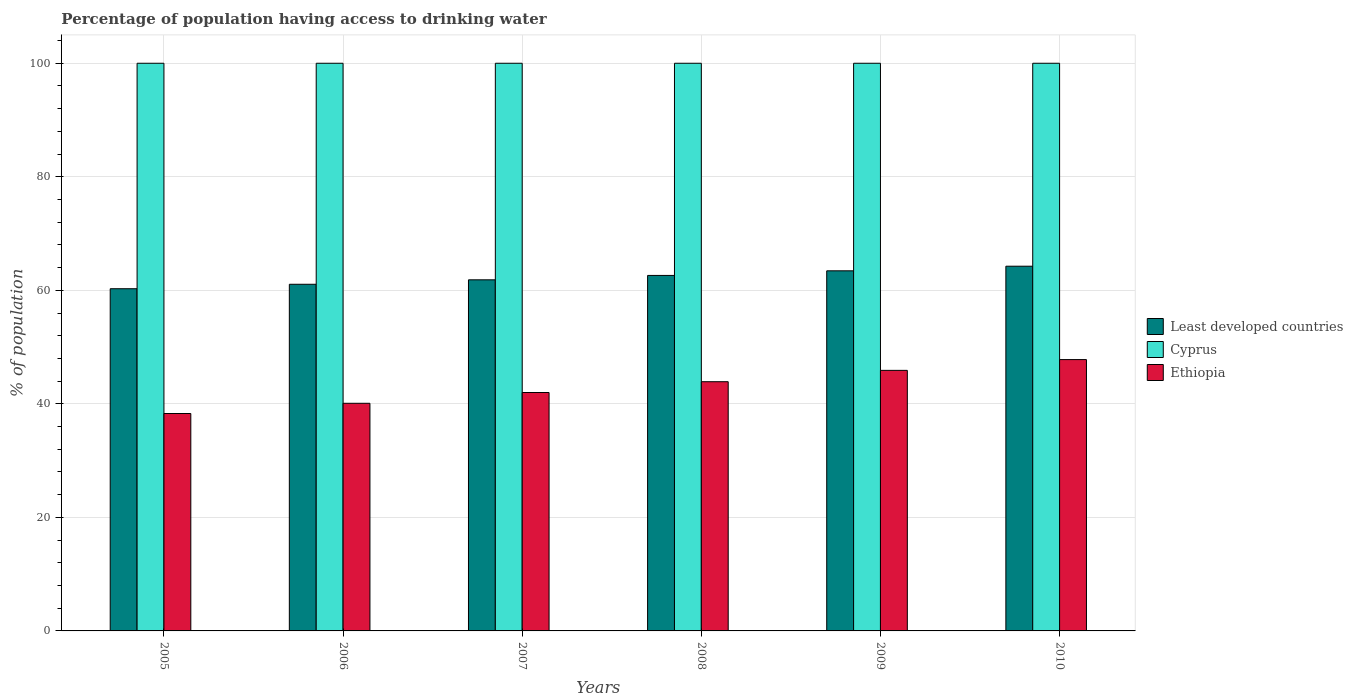How many different coloured bars are there?
Keep it short and to the point. 3. Are the number of bars per tick equal to the number of legend labels?
Your answer should be compact. Yes. What is the label of the 2nd group of bars from the left?
Your response must be concise. 2006. What is the percentage of population having access to drinking water in Least developed countries in 2007?
Your answer should be compact. 61.85. Across all years, what is the maximum percentage of population having access to drinking water in Ethiopia?
Your response must be concise. 47.8. Across all years, what is the minimum percentage of population having access to drinking water in Ethiopia?
Provide a succinct answer. 38.3. In which year was the percentage of population having access to drinking water in Cyprus minimum?
Offer a terse response. 2005. What is the total percentage of population having access to drinking water in Cyprus in the graph?
Make the answer very short. 600. What is the difference between the percentage of population having access to drinking water in Least developed countries in 2008 and that in 2010?
Your answer should be compact. -1.62. What is the difference between the percentage of population having access to drinking water in Ethiopia in 2007 and the percentage of population having access to drinking water in Cyprus in 2006?
Keep it short and to the point. -58. In the year 2007, what is the difference between the percentage of population having access to drinking water in Least developed countries and percentage of population having access to drinking water in Cyprus?
Offer a terse response. -38.15. In how many years, is the percentage of population having access to drinking water in Least developed countries greater than 44 %?
Provide a succinct answer. 6. What is the ratio of the percentage of population having access to drinking water in Cyprus in 2008 to that in 2009?
Keep it short and to the point. 1. Is the difference between the percentage of population having access to drinking water in Least developed countries in 2007 and 2010 greater than the difference between the percentage of population having access to drinking water in Cyprus in 2007 and 2010?
Your response must be concise. No. What is the difference between the highest and the second highest percentage of population having access to drinking water in Ethiopia?
Your response must be concise. 1.9. What is the difference between the highest and the lowest percentage of population having access to drinking water in Cyprus?
Offer a very short reply. 0. In how many years, is the percentage of population having access to drinking water in Cyprus greater than the average percentage of population having access to drinking water in Cyprus taken over all years?
Ensure brevity in your answer.  0. Is the sum of the percentage of population having access to drinking water in Ethiopia in 2006 and 2010 greater than the maximum percentage of population having access to drinking water in Least developed countries across all years?
Keep it short and to the point. Yes. What does the 3rd bar from the left in 2008 represents?
Offer a terse response. Ethiopia. What does the 3rd bar from the right in 2006 represents?
Your response must be concise. Least developed countries. How many years are there in the graph?
Offer a very short reply. 6. Are the values on the major ticks of Y-axis written in scientific E-notation?
Offer a terse response. No. Does the graph contain any zero values?
Offer a very short reply. No. Does the graph contain grids?
Provide a short and direct response. Yes. Where does the legend appear in the graph?
Your answer should be very brief. Center right. How many legend labels are there?
Make the answer very short. 3. What is the title of the graph?
Keep it short and to the point. Percentage of population having access to drinking water. What is the label or title of the Y-axis?
Make the answer very short. % of population. What is the % of population of Least developed countries in 2005?
Give a very brief answer. 60.28. What is the % of population in Ethiopia in 2005?
Offer a terse response. 38.3. What is the % of population of Least developed countries in 2006?
Offer a terse response. 61.06. What is the % of population of Ethiopia in 2006?
Provide a short and direct response. 40.1. What is the % of population in Least developed countries in 2007?
Offer a very short reply. 61.85. What is the % of population in Cyprus in 2007?
Keep it short and to the point. 100. What is the % of population of Least developed countries in 2008?
Make the answer very short. 62.62. What is the % of population of Cyprus in 2008?
Make the answer very short. 100. What is the % of population of Ethiopia in 2008?
Your answer should be compact. 43.9. What is the % of population of Least developed countries in 2009?
Give a very brief answer. 63.44. What is the % of population in Cyprus in 2009?
Offer a very short reply. 100. What is the % of population of Ethiopia in 2009?
Make the answer very short. 45.9. What is the % of population in Least developed countries in 2010?
Your response must be concise. 64.25. What is the % of population of Ethiopia in 2010?
Make the answer very short. 47.8. Across all years, what is the maximum % of population in Least developed countries?
Ensure brevity in your answer.  64.25. Across all years, what is the maximum % of population in Cyprus?
Offer a very short reply. 100. Across all years, what is the maximum % of population of Ethiopia?
Your answer should be very brief. 47.8. Across all years, what is the minimum % of population of Least developed countries?
Your answer should be compact. 60.28. Across all years, what is the minimum % of population of Ethiopia?
Your answer should be compact. 38.3. What is the total % of population of Least developed countries in the graph?
Your answer should be very brief. 373.5. What is the total % of population of Cyprus in the graph?
Provide a short and direct response. 600. What is the total % of population of Ethiopia in the graph?
Offer a very short reply. 258. What is the difference between the % of population of Least developed countries in 2005 and that in 2006?
Your response must be concise. -0.78. What is the difference between the % of population of Cyprus in 2005 and that in 2006?
Your answer should be compact. 0. What is the difference between the % of population in Least developed countries in 2005 and that in 2007?
Provide a short and direct response. -1.57. What is the difference between the % of population of Least developed countries in 2005 and that in 2008?
Make the answer very short. -2.34. What is the difference between the % of population of Least developed countries in 2005 and that in 2009?
Keep it short and to the point. -3.15. What is the difference between the % of population of Least developed countries in 2005 and that in 2010?
Provide a short and direct response. -3.97. What is the difference between the % of population of Ethiopia in 2005 and that in 2010?
Keep it short and to the point. -9.5. What is the difference between the % of population in Least developed countries in 2006 and that in 2007?
Your response must be concise. -0.78. What is the difference between the % of population of Cyprus in 2006 and that in 2007?
Ensure brevity in your answer.  0. What is the difference between the % of population in Ethiopia in 2006 and that in 2007?
Your response must be concise. -1.9. What is the difference between the % of population in Least developed countries in 2006 and that in 2008?
Offer a very short reply. -1.56. What is the difference between the % of population of Least developed countries in 2006 and that in 2009?
Provide a succinct answer. -2.37. What is the difference between the % of population of Least developed countries in 2006 and that in 2010?
Keep it short and to the point. -3.18. What is the difference between the % of population in Least developed countries in 2007 and that in 2008?
Keep it short and to the point. -0.77. What is the difference between the % of population of Cyprus in 2007 and that in 2008?
Ensure brevity in your answer.  0. What is the difference between the % of population in Least developed countries in 2007 and that in 2009?
Your response must be concise. -1.59. What is the difference between the % of population in Least developed countries in 2007 and that in 2010?
Keep it short and to the point. -2.4. What is the difference between the % of population in Least developed countries in 2008 and that in 2009?
Offer a very short reply. -0.81. What is the difference between the % of population of Ethiopia in 2008 and that in 2009?
Your answer should be compact. -2. What is the difference between the % of population in Least developed countries in 2008 and that in 2010?
Your response must be concise. -1.62. What is the difference between the % of population of Cyprus in 2008 and that in 2010?
Provide a short and direct response. 0. What is the difference between the % of population of Least developed countries in 2009 and that in 2010?
Make the answer very short. -0.81. What is the difference between the % of population of Ethiopia in 2009 and that in 2010?
Ensure brevity in your answer.  -1.9. What is the difference between the % of population in Least developed countries in 2005 and the % of population in Cyprus in 2006?
Offer a terse response. -39.72. What is the difference between the % of population in Least developed countries in 2005 and the % of population in Ethiopia in 2006?
Offer a terse response. 20.18. What is the difference between the % of population in Cyprus in 2005 and the % of population in Ethiopia in 2006?
Provide a succinct answer. 59.9. What is the difference between the % of population in Least developed countries in 2005 and the % of population in Cyprus in 2007?
Provide a succinct answer. -39.72. What is the difference between the % of population in Least developed countries in 2005 and the % of population in Ethiopia in 2007?
Keep it short and to the point. 18.28. What is the difference between the % of population in Least developed countries in 2005 and the % of population in Cyprus in 2008?
Keep it short and to the point. -39.72. What is the difference between the % of population in Least developed countries in 2005 and the % of population in Ethiopia in 2008?
Your answer should be very brief. 16.38. What is the difference between the % of population in Cyprus in 2005 and the % of population in Ethiopia in 2008?
Give a very brief answer. 56.1. What is the difference between the % of population of Least developed countries in 2005 and the % of population of Cyprus in 2009?
Make the answer very short. -39.72. What is the difference between the % of population of Least developed countries in 2005 and the % of population of Ethiopia in 2009?
Your answer should be compact. 14.38. What is the difference between the % of population of Cyprus in 2005 and the % of population of Ethiopia in 2009?
Your answer should be compact. 54.1. What is the difference between the % of population in Least developed countries in 2005 and the % of population in Cyprus in 2010?
Give a very brief answer. -39.72. What is the difference between the % of population in Least developed countries in 2005 and the % of population in Ethiopia in 2010?
Your answer should be compact. 12.48. What is the difference between the % of population of Cyprus in 2005 and the % of population of Ethiopia in 2010?
Provide a succinct answer. 52.2. What is the difference between the % of population of Least developed countries in 2006 and the % of population of Cyprus in 2007?
Your response must be concise. -38.94. What is the difference between the % of population in Least developed countries in 2006 and the % of population in Ethiopia in 2007?
Provide a succinct answer. 19.06. What is the difference between the % of population in Cyprus in 2006 and the % of population in Ethiopia in 2007?
Provide a succinct answer. 58. What is the difference between the % of population in Least developed countries in 2006 and the % of population in Cyprus in 2008?
Keep it short and to the point. -38.94. What is the difference between the % of population in Least developed countries in 2006 and the % of population in Ethiopia in 2008?
Provide a short and direct response. 17.16. What is the difference between the % of population of Cyprus in 2006 and the % of population of Ethiopia in 2008?
Your answer should be compact. 56.1. What is the difference between the % of population in Least developed countries in 2006 and the % of population in Cyprus in 2009?
Give a very brief answer. -38.94. What is the difference between the % of population in Least developed countries in 2006 and the % of population in Ethiopia in 2009?
Give a very brief answer. 15.16. What is the difference between the % of population in Cyprus in 2006 and the % of population in Ethiopia in 2009?
Offer a very short reply. 54.1. What is the difference between the % of population in Least developed countries in 2006 and the % of population in Cyprus in 2010?
Your answer should be very brief. -38.94. What is the difference between the % of population of Least developed countries in 2006 and the % of population of Ethiopia in 2010?
Offer a very short reply. 13.26. What is the difference between the % of population in Cyprus in 2006 and the % of population in Ethiopia in 2010?
Your answer should be very brief. 52.2. What is the difference between the % of population of Least developed countries in 2007 and the % of population of Cyprus in 2008?
Provide a succinct answer. -38.15. What is the difference between the % of population in Least developed countries in 2007 and the % of population in Ethiopia in 2008?
Give a very brief answer. 17.95. What is the difference between the % of population in Cyprus in 2007 and the % of population in Ethiopia in 2008?
Provide a short and direct response. 56.1. What is the difference between the % of population in Least developed countries in 2007 and the % of population in Cyprus in 2009?
Provide a short and direct response. -38.15. What is the difference between the % of population of Least developed countries in 2007 and the % of population of Ethiopia in 2009?
Make the answer very short. 15.95. What is the difference between the % of population in Cyprus in 2007 and the % of population in Ethiopia in 2009?
Give a very brief answer. 54.1. What is the difference between the % of population of Least developed countries in 2007 and the % of population of Cyprus in 2010?
Provide a short and direct response. -38.15. What is the difference between the % of population of Least developed countries in 2007 and the % of population of Ethiopia in 2010?
Provide a succinct answer. 14.05. What is the difference between the % of population in Cyprus in 2007 and the % of population in Ethiopia in 2010?
Provide a succinct answer. 52.2. What is the difference between the % of population in Least developed countries in 2008 and the % of population in Cyprus in 2009?
Give a very brief answer. -37.38. What is the difference between the % of population of Least developed countries in 2008 and the % of population of Ethiopia in 2009?
Keep it short and to the point. 16.72. What is the difference between the % of population of Cyprus in 2008 and the % of population of Ethiopia in 2009?
Make the answer very short. 54.1. What is the difference between the % of population in Least developed countries in 2008 and the % of population in Cyprus in 2010?
Your answer should be very brief. -37.38. What is the difference between the % of population of Least developed countries in 2008 and the % of population of Ethiopia in 2010?
Provide a succinct answer. 14.82. What is the difference between the % of population in Cyprus in 2008 and the % of population in Ethiopia in 2010?
Ensure brevity in your answer.  52.2. What is the difference between the % of population of Least developed countries in 2009 and the % of population of Cyprus in 2010?
Your answer should be very brief. -36.56. What is the difference between the % of population in Least developed countries in 2009 and the % of population in Ethiopia in 2010?
Give a very brief answer. 15.64. What is the difference between the % of population of Cyprus in 2009 and the % of population of Ethiopia in 2010?
Offer a very short reply. 52.2. What is the average % of population of Least developed countries per year?
Offer a very short reply. 62.25. What is the average % of population in Ethiopia per year?
Your response must be concise. 43. In the year 2005, what is the difference between the % of population in Least developed countries and % of population in Cyprus?
Make the answer very short. -39.72. In the year 2005, what is the difference between the % of population in Least developed countries and % of population in Ethiopia?
Make the answer very short. 21.98. In the year 2005, what is the difference between the % of population in Cyprus and % of population in Ethiopia?
Provide a succinct answer. 61.7. In the year 2006, what is the difference between the % of population in Least developed countries and % of population in Cyprus?
Provide a succinct answer. -38.94. In the year 2006, what is the difference between the % of population of Least developed countries and % of population of Ethiopia?
Keep it short and to the point. 20.96. In the year 2006, what is the difference between the % of population of Cyprus and % of population of Ethiopia?
Your answer should be compact. 59.9. In the year 2007, what is the difference between the % of population in Least developed countries and % of population in Cyprus?
Provide a succinct answer. -38.15. In the year 2007, what is the difference between the % of population of Least developed countries and % of population of Ethiopia?
Ensure brevity in your answer.  19.85. In the year 2007, what is the difference between the % of population in Cyprus and % of population in Ethiopia?
Ensure brevity in your answer.  58. In the year 2008, what is the difference between the % of population of Least developed countries and % of population of Cyprus?
Offer a very short reply. -37.38. In the year 2008, what is the difference between the % of population in Least developed countries and % of population in Ethiopia?
Provide a short and direct response. 18.72. In the year 2008, what is the difference between the % of population of Cyprus and % of population of Ethiopia?
Offer a terse response. 56.1. In the year 2009, what is the difference between the % of population in Least developed countries and % of population in Cyprus?
Make the answer very short. -36.56. In the year 2009, what is the difference between the % of population of Least developed countries and % of population of Ethiopia?
Give a very brief answer. 17.54. In the year 2009, what is the difference between the % of population of Cyprus and % of population of Ethiopia?
Keep it short and to the point. 54.1. In the year 2010, what is the difference between the % of population of Least developed countries and % of population of Cyprus?
Your answer should be compact. -35.75. In the year 2010, what is the difference between the % of population in Least developed countries and % of population in Ethiopia?
Your answer should be very brief. 16.45. In the year 2010, what is the difference between the % of population of Cyprus and % of population of Ethiopia?
Keep it short and to the point. 52.2. What is the ratio of the % of population of Least developed countries in 2005 to that in 2006?
Offer a very short reply. 0.99. What is the ratio of the % of population in Ethiopia in 2005 to that in 2006?
Provide a succinct answer. 0.96. What is the ratio of the % of population of Least developed countries in 2005 to that in 2007?
Your answer should be very brief. 0.97. What is the ratio of the % of population of Ethiopia in 2005 to that in 2007?
Your answer should be very brief. 0.91. What is the ratio of the % of population in Least developed countries in 2005 to that in 2008?
Provide a succinct answer. 0.96. What is the ratio of the % of population in Ethiopia in 2005 to that in 2008?
Your response must be concise. 0.87. What is the ratio of the % of population in Least developed countries in 2005 to that in 2009?
Offer a terse response. 0.95. What is the ratio of the % of population of Cyprus in 2005 to that in 2009?
Your answer should be compact. 1. What is the ratio of the % of population of Ethiopia in 2005 to that in 2009?
Your answer should be compact. 0.83. What is the ratio of the % of population of Least developed countries in 2005 to that in 2010?
Provide a short and direct response. 0.94. What is the ratio of the % of population in Ethiopia in 2005 to that in 2010?
Offer a very short reply. 0.8. What is the ratio of the % of population in Least developed countries in 2006 to that in 2007?
Make the answer very short. 0.99. What is the ratio of the % of population in Cyprus in 2006 to that in 2007?
Your answer should be compact. 1. What is the ratio of the % of population in Ethiopia in 2006 to that in 2007?
Make the answer very short. 0.95. What is the ratio of the % of population in Least developed countries in 2006 to that in 2008?
Your answer should be compact. 0.98. What is the ratio of the % of population in Cyprus in 2006 to that in 2008?
Offer a very short reply. 1. What is the ratio of the % of population in Ethiopia in 2006 to that in 2008?
Provide a succinct answer. 0.91. What is the ratio of the % of population in Least developed countries in 2006 to that in 2009?
Your answer should be compact. 0.96. What is the ratio of the % of population in Ethiopia in 2006 to that in 2009?
Your response must be concise. 0.87. What is the ratio of the % of population in Least developed countries in 2006 to that in 2010?
Make the answer very short. 0.95. What is the ratio of the % of population of Cyprus in 2006 to that in 2010?
Your answer should be very brief. 1. What is the ratio of the % of population of Ethiopia in 2006 to that in 2010?
Give a very brief answer. 0.84. What is the ratio of the % of population of Least developed countries in 2007 to that in 2008?
Offer a very short reply. 0.99. What is the ratio of the % of population of Ethiopia in 2007 to that in 2008?
Your answer should be compact. 0.96. What is the ratio of the % of population in Least developed countries in 2007 to that in 2009?
Your response must be concise. 0.97. What is the ratio of the % of population of Ethiopia in 2007 to that in 2009?
Your answer should be compact. 0.92. What is the ratio of the % of population in Least developed countries in 2007 to that in 2010?
Ensure brevity in your answer.  0.96. What is the ratio of the % of population in Ethiopia in 2007 to that in 2010?
Provide a short and direct response. 0.88. What is the ratio of the % of population of Least developed countries in 2008 to that in 2009?
Your answer should be very brief. 0.99. What is the ratio of the % of population in Cyprus in 2008 to that in 2009?
Make the answer very short. 1. What is the ratio of the % of population in Ethiopia in 2008 to that in 2009?
Give a very brief answer. 0.96. What is the ratio of the % of population of Least developed countries in 2008 to that in 2010?
Give a very brief answer. 0.97. What is the ratio of the % of population in Ethiopia in 2008 to that in 2010?
Keep it short and to the point. 0.92. What is the ratio of the % of population in Least developed countries in 2009 to that in 2010?
Offer a very short reply. 0.99. What is the ratio of the % of population of Cyprus in 2009 to that in 2010?
Your response must be concise. 1. What is the ratio of the % of population of Ethiopia in 2009 to that in 2010?
Ensure brevity in your answer.  0.96. What is the difference between the highest and the second highest % of population in Least developed countries?
Make the answer very short. 0.81. What is the difference between the highest and the second highest % of population of Cyprus?
Your answer should be compact. 0. What is the difference between the highest and the second highest % of population in Ethiopia?
Your answer should be compact. 1.9. What is the difference between the highest and the lowest % of population in Least developed countries?
Your answer should be compact. 3.97. 